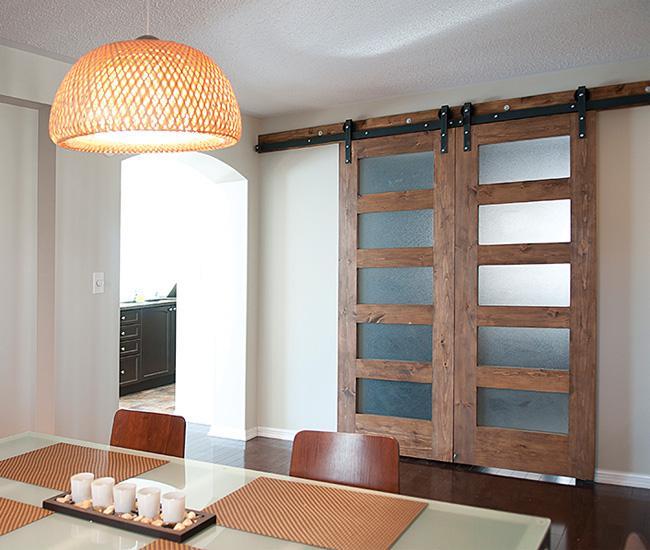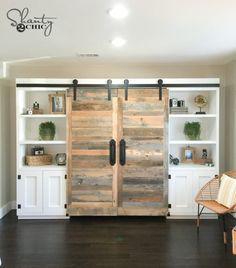The first image is the image on the left, the second image is the image on the right. For the images shown, is this caption "An image shows 'barn doors' that slide on a black bar overhead, above a wide dresser with lamps on each end." true? Answer yes or no. No. The first image is the image on the left, the second image is the image on the right. Considering the images on both sides, is "A sliding television cabinet is open." valid? Answer yes or no. No. 